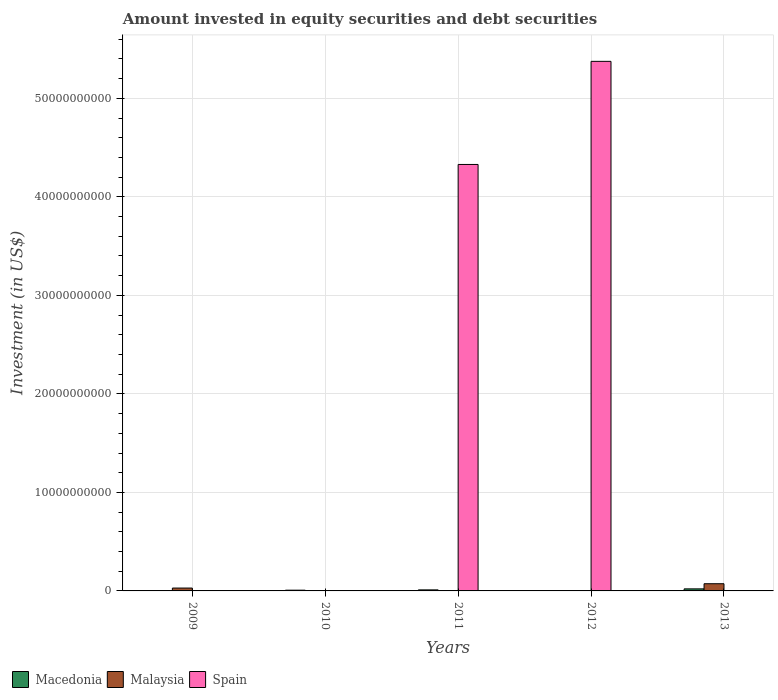Are the number of bars per tick equal to the number of legend labels?
Provide a short and direct response. No. What is the label of the 5th group of bars from the left?
Provide a short and direct response. 2013. What is the amount invested in equity securities and debt securities in Malaysia in 2010?
Provide a succinct answer. 0. Across all years, what is the maximum amount invested in equity securities and debt securities in Macedonia?
Offer a very short reply. 2.09e+08. Across all years, what is the minimum amount invested in equity securities and debt securities in Spain?
Provide a short and direct response. 0. In which year was the amount invested in equity securities and debt securities in Malaysia maximum?
Make the answer very short. 2013. What is the total amount invested in equity securities and debt securities in Macedonia in the graph?
Make the answer very short. 3.91e+08. What is the difference between the amount invested in equity securities and debt securities in Macedonia in 2011 and the amount invested in equity securities and debt securities in Malaysia in 2010?
Your answer should be compact. 1.06e+08. What is the average amount invested in equity securities and debt securities in Malaysia per year?
Provide a succinct answer. 2.04e+08. In the year 2013, what is the difference between the amount invested in equity securities and debt securities in Malaysia and amount invested in equity securities and debt securities in Macedonia?
Provide a short and direct response. 5.22e+08. In how many years, is the amount invested in equity securities and debt securities in Malaysia greater than 30000000000 US$?
Your answer should be compact. 0. What is the ratio of the amount invested in equity securities and debt securities in Malaysia in 2009 to that in 2013?
Your answer should be very brief. 0.4. What is the difference between the highest and the lowest amount invested in equity securities and debt securities in Spain?
Your answer should be very brief. 5.38e+1. Are all the bars in the graph horizontal?
Give a very brief answer. No. Are the values on the major ticks of Y-axis written in scientific E-notation?
Keep it short and to the point. No. Where does the legend appear in the graph?
Provide a short and direct response. Bottom left. What is the title of the graph?
Provide a short and direct response. Amount invested in equity securities and debt securities. Does "Afghanistan" appear as one of the legend labels in the graph?
Keep it short and to the point. No. What is the label or title of the X-axis?
Ensure brevity in your answer.  Years. What is the label or title of the Y-axis?
Your response must be concise. Investment (in US$). What is the Investment (in US$) of Macedonia in 2009?
Your answer should be compact. 0. What is the Investment (in US$) of Malaysia in 2009?
Ensure brevity in your answer.  2.91e+08. What is the Investment (in US$) in Macedonia in 2010?
Your response must be concise. 7.59e+07. What is the Investment (in US$) of Macedonia in 2011?
Your answer should be very brief. 1.06e+08. What is the Investment (in US$) in Malaysia in 2011?
Provide a short and direct response. 0. What is the Investment (in US$) in Spain in 2011?
Your response must be concise. 4.33e+1. What is the Investment (in US$) in Spain in 2012?
Provide a short and direct response. 5.38e+1. What is the Investment (in US$) of Macedonia in 2013?
Offer a very short reply. 2.09e+08. What is the Investment (in US$) of Malaysia in 2013?
Keep it short and to the point. 7.31e+08. What is the Investment (in US$) in Spain in 2013?
Ensure brevity in your answer.  0. Across all years, what is the maximum Investment (in US$) of Macedonia?
Your response must be concise. 2.09e+08. Across all years, what is the maximum Investment (in US$) of Malaysia?
Offer a terse response. 7.31e+08. Across all years, what is the maximum Investment (in US$) of Spain?
Give a very brief answer. 5.38e+1. Across all years, what is the minimum Investment (in US$) of Macedonia?
Offer a terse response. 0. Across all years, what is the minimum Investment (in US$) of Malaysia?
Offer a very short reply. 0. Across all years, what is the minimum Investment (in US$) in Spain?
Ensure brevity in your answer.  0. What is the total Investment (in US$) in Macedonia in the graph?
Offer a terse response. 3.91e+08. What is the total Investment (in US$) in Malaysia in the graph?
Your answer should be very brief. 1.02e+09. What is the total Investment (in US$) in Spain in the graph?
Give a very brief answer. 9.71e+1. What is the difference between the Investment (in US$) of Malaysia in 2009 and that in 2013?
Provide a short and direct response. -4.40e+08. What is the difference between the Investment (in US$) in Macedonia in 2010 and that in 2011?
Keep it short and to the point. -3.03e+07. What is the difference between the Investment (in US$) of Macedonia in 2010 and that in 2013?
Keep it short and to the point. -1.33e+08. What is the difference between the Investment (in US$) in Spain in 2011 and that in 2012?
Provide a short and direct response. -1.05e+1. What is the difference between the Investment (in US$) of Macedonia in 2011 and that in 2013?
Your response must be concise. -1.03e+08. What is the difference between the Investment (in US$) in Malaysia in 2009 and the Investment (in US$) in Spain in 2011?
Your answer should be compact. -4.30e+1. What is the difference between the Investment (in US$) of Malaysia in 2009 and the Investment (in US$) of Spain in 2012?
Your response must be concise. -5.35e+1. What is the difference between the Investment (in US$) of Macedonia in 2010 and the Investment (in US$) of Spain in 2011?
Make the answer very short. -4.32e+1. What is the difference between the Investment (in US$) in Macedonia in 2010 and the Investment (in US$) in Spain in 2012?
Provide a succinct answer. -5.37e+1. What is the difference between the Investment (in US$) in Macedonia in 2010 and the Investment (in US$) in Malaysia in 2013?
Offer a terse response. -6.55e+08. What is the difference between the Investment (in US$) of Macedonia in 2011 and the Investment (in US$) of Spain in 2012?
Keep it short and to the point. -5.37e+1. What is the difference between the Investment (in US$) of Macedonia in 2011 and the Investment (in US$) of Malaysia in 2013?
Offer a terse response. -6.25e+08. What is the average Investment (in US$) in Macedonia per year?
Offer a terse response. 7.82e+07. What is the average Investment (in US$) in Malaysia per year?
Your response must be concise. 2.04e+08. What is the average Investment (in US$) of Spain per year?
Provide a short and direct response. 1.94e+1. In the year 2011, what is the difference between the Investment (in US$) in Macedonia and Investment (in US$) in Spain?
Keep it short and to the point. -4.32e+1. In the year 2013, what is the difference between the Investment (in US$) in Macedonia and Investment (in US$) in Malaysia?
Offer a terse response. -5.22e+08. What is the ratio of the Investment (in US$) in Malaysia in 2009 to that in 2013?
Offer a terse response. 0.4. What is the ratio of the Investment (in US$) of Macedonia in 2010 to that in 2011?
Your answer should be compact. 0.71. What is the ratio of the Investment (in US$) in Macedonia in 2010 to that in 2013?
Offer a terse response. 0.36. What is the ratio of the Investment (in US$) of Spain in 2011 to that in 2012?
Your answer should be very brief. 0.81. What is the ratio of the Investment (in US$) in Macedonia in 2011 to that in 2013?
Make the answer very short. 0.51. What is the difference between the highest and the second highest Investment (in US$) in Macedonia?
Ensure brevity in your answer.  1.03e+08. What is the difference between the highest and the lowest Investment (in US$) in Macedonia?
Your answer should be very brief. 2.09e+08. What is the difference between the highest and the lowest Investment (in US$) of Malaysia?
Ensure brevity in your answer.  7.31e+08. What is the difference between the highest and the lowest Investment (in US$) in Spain?
Provide a succinct answer. 5.38e+1. 